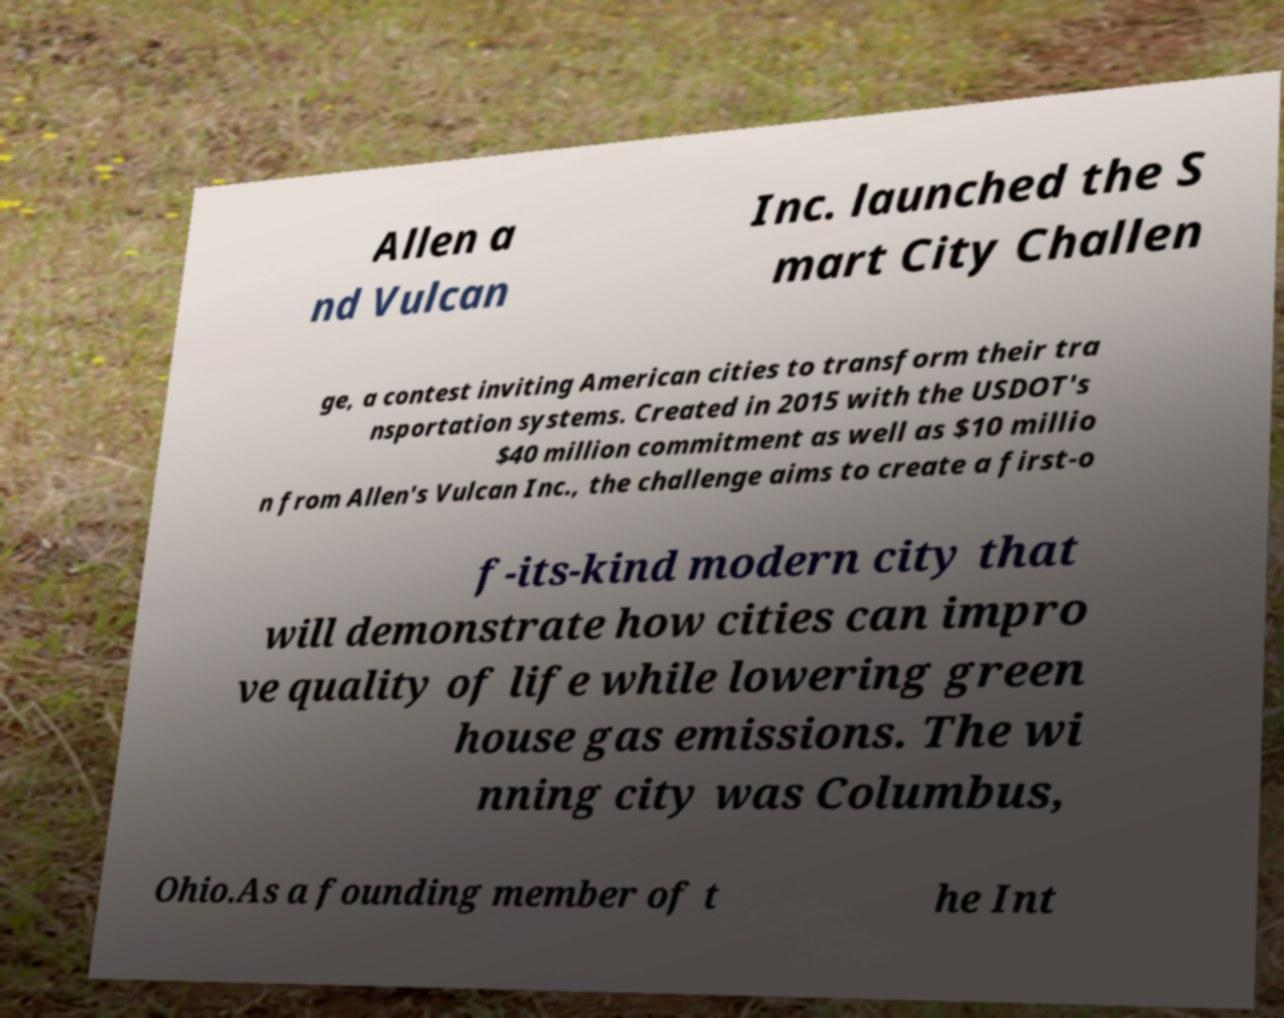I need the written content from this picture converted into text. Can you do that? Allen a nd Vulcan Inc. launched the S mart City Challen ge, a contest inviting American cities to transform their tra nsportation systems. Created in 2015 with the USDOT's $40 million commitment as well as $10 millio n from Allen's Vulcan Inc., the challenge aims to create a first-o f-its-kind modern city that will demonstrate how cities can impro ve quality of life while lowering green house gas emissions. The wi nning city was Columbus, Ohio.As a founding member of t he Int 